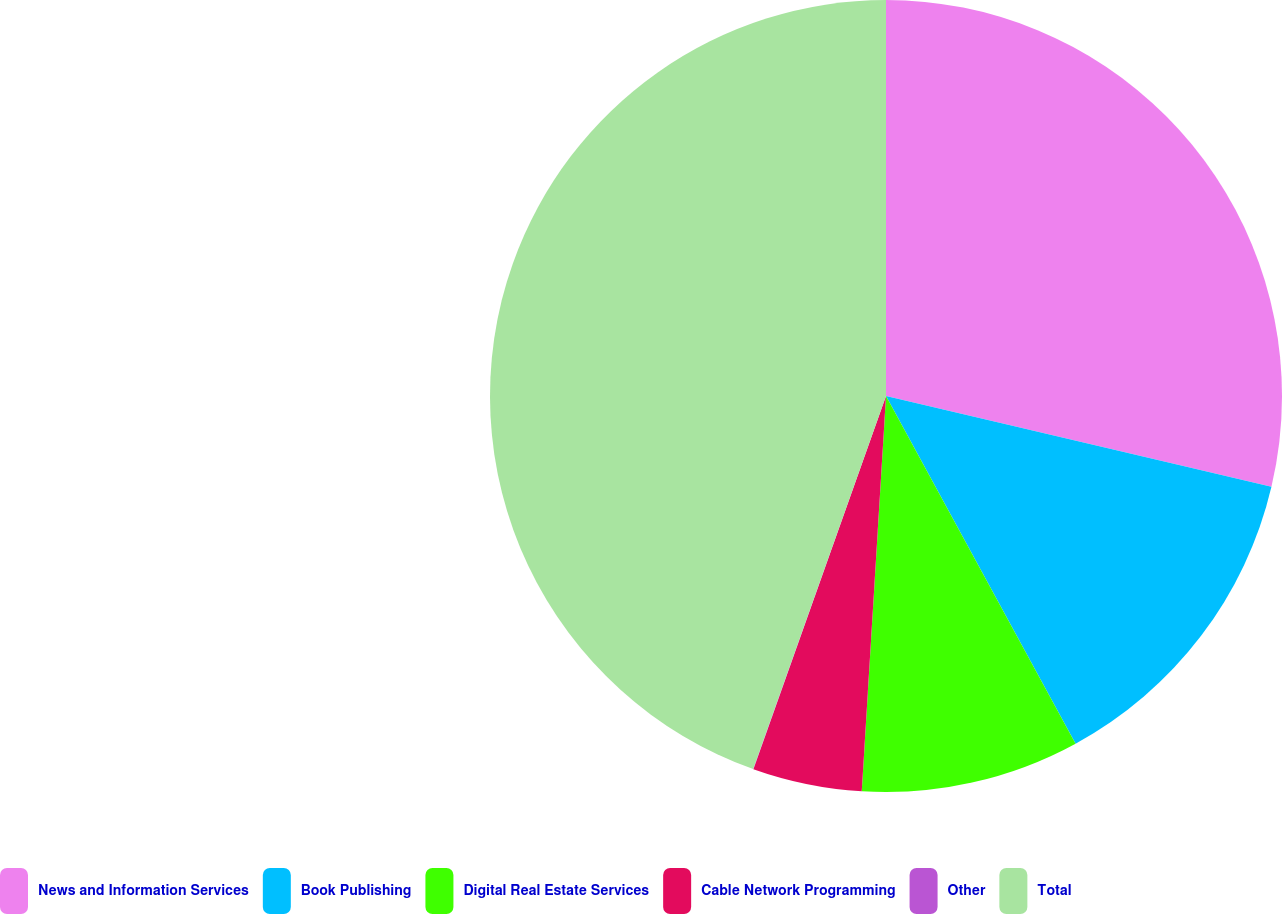<chart> <loc_0><loc_0><loc_500><loc_500><pie_chart><fcel>News and Information Services<fcel>Book Publishing<fcel>Digital Real Estate Services<fcel>Cable Network Programming<fcel>Other<fcel>Total<nl><fcel>28.68%<fcel>13.37%<fcel>8.92%<fcel>4.46%<fcel>0.01%<fcel>44.55%<nl></chart> 